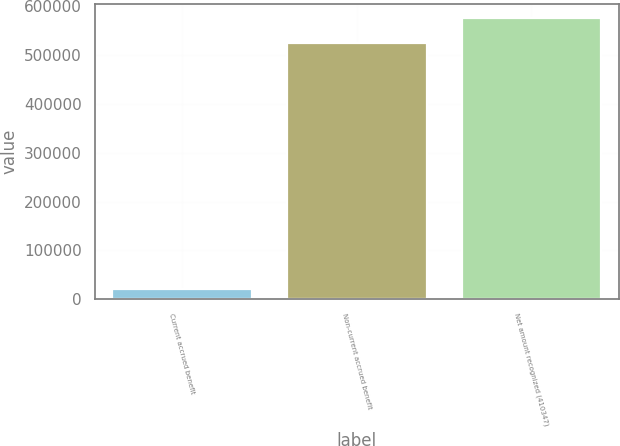Convert chart to OTSL. <chart><loc_0><loc_0><loc_500><loc_500><bar_chart><fcel>Current accrued benefit<fcel>Non-current accrued benefit<fcel>Net amount recognized (410347)<nl><fcel>21574<fcel>523758<fcel>576134<nl></chart> 